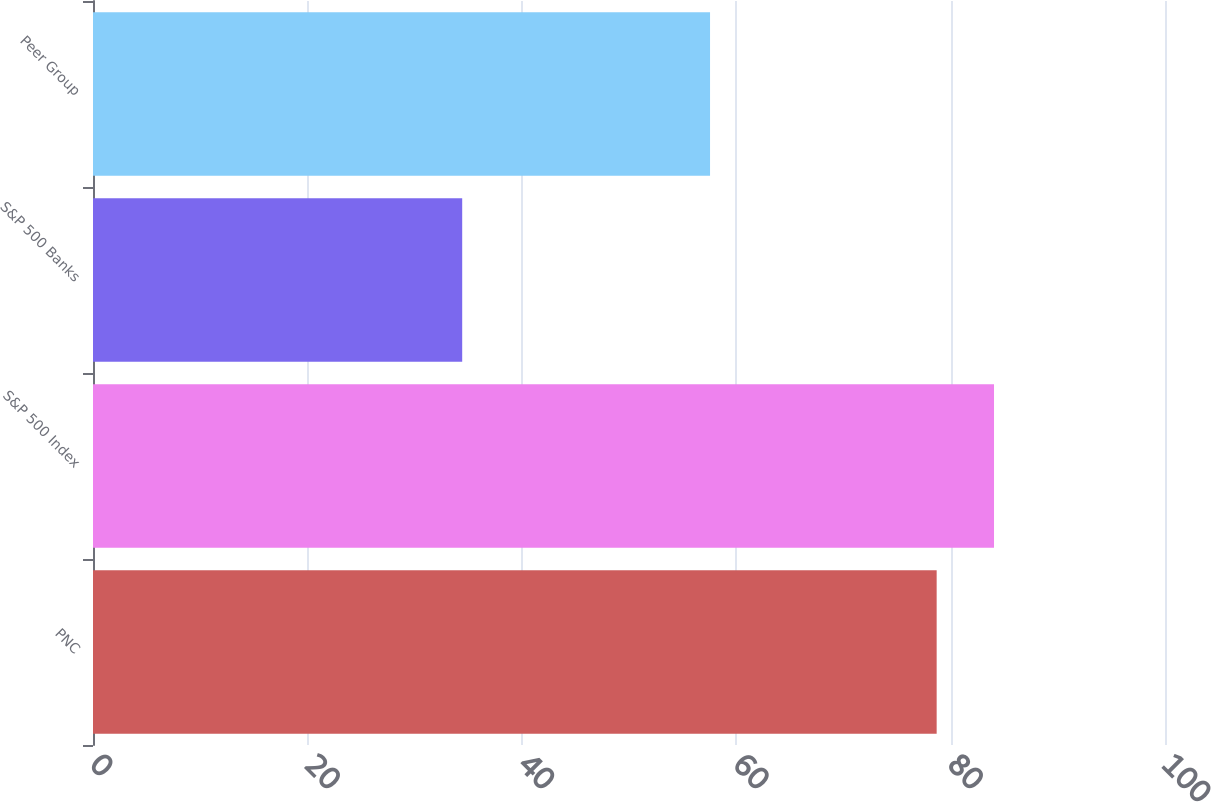Convert chart. <chart><loc_0><loc_0><loc_500><loc_500><bar_chart><fcel>PNC<fcel>S&P 500 Index<fcel>S&P 500 Banks<fcel>Peer Group<nl><fcel>78.7<fcel>84.05<fcel>34.44<fcel>57.56<nl></chart> 